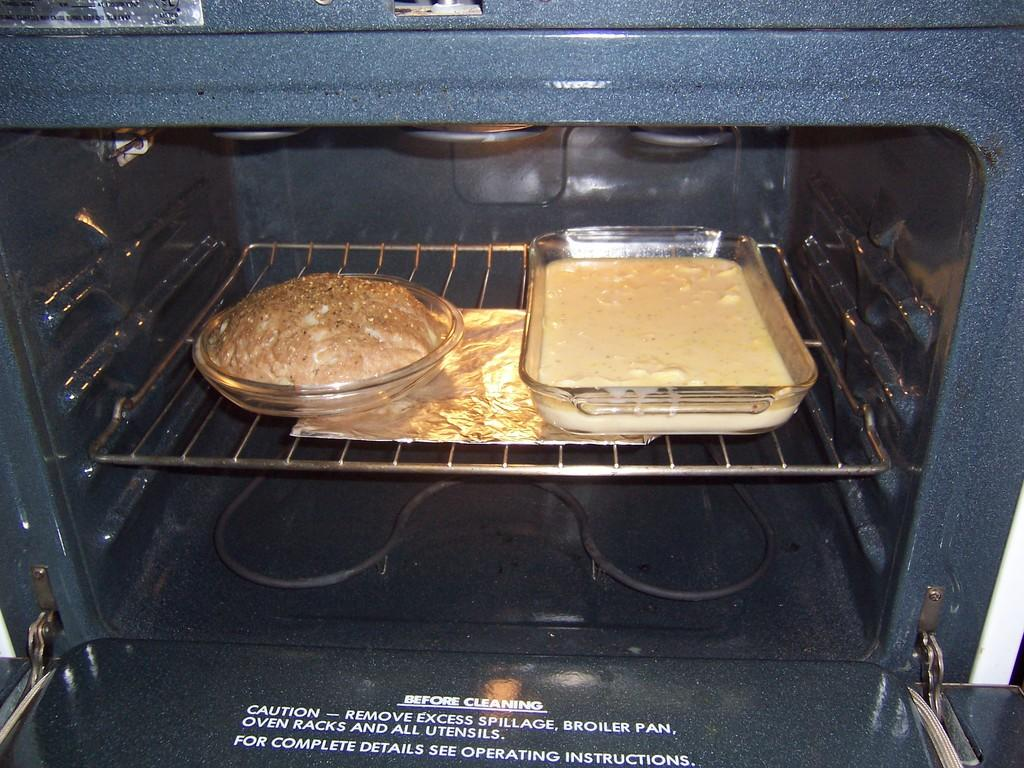<image>
Share a concise interpretation of the image provided. Two cake pans are inside an oven with the words "Before Cleaning" on the open oven door. 